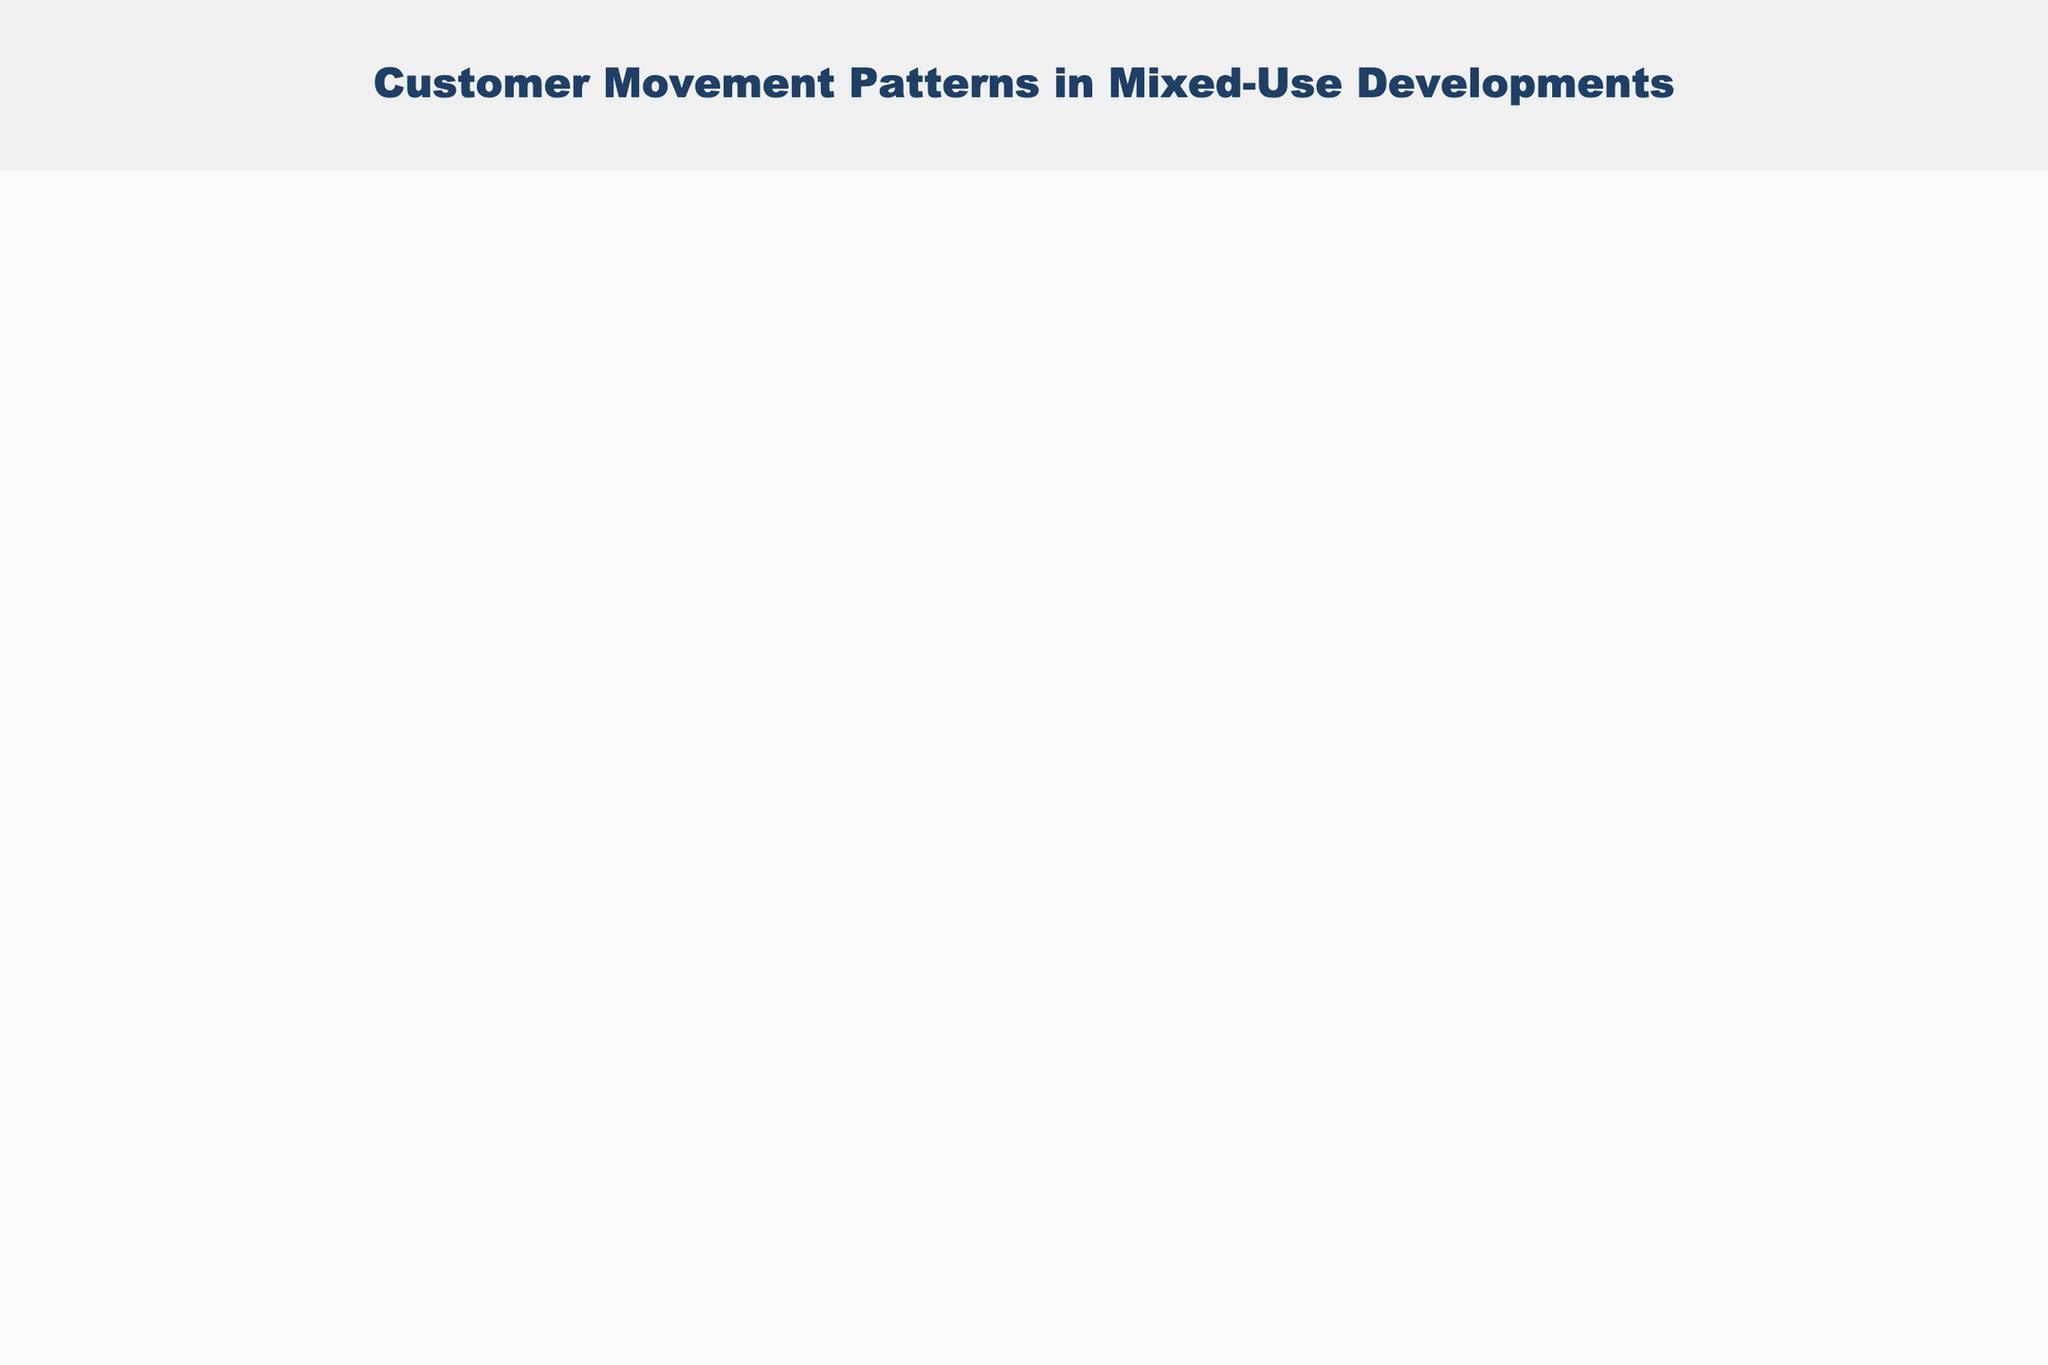What's the title of the quiver plot? The title of the quiver plot is written at the top of the plot.
Answer: "Customer Movement Patterns in Mixed-Use Developments" What are the ranges of the x and y axes? The x and y-axis ranges can be seen on the figure, indicated by the graduated tick marks and axis labels ranging from -1 to 6.
Answer: x: [-1, 6], y: [-1, 6] What does the annotation below the plot say? The annotation text is placed below the plot and provides context about the data.
Answer: "Data represents customer movement vectors in a retail space" How many data points are shown in the plot? The number of non-overlapping vectors represents the data points. Counting each vector head and tail visible in the figure will give the total number.
Answer: 15 Which vector has the longest magnitude, and what is its value? The vector magnitude is related to the arrow size; the longest arrow corresponds to the highest magnitude. The longest vector is at (1,4) with magnitude 3.0.
Answer: (1, 4), 3.0 Are there any vectors where movement is purely horizontal or vertical? To identify purely horizontal or vertical vectors, look for ones where either the u or v component is zero, respectively.
Answer: (4,3) is purely vertical, (1,4) is purely horizontal What is the color theme used for this plot? The color theme represents the magnitude of movement patterns; check the colors at each arrow to confirm the color scheme.
Answer: Viridis Which vectors start from the coordinates (0,0) and (2,1)? Reviewing the starting points in the data and comparing them with the plotted vectors we find these vectors easily. (0,0) is (2,1); (2,1) is (-1,2).
Answer: (0,0)=(2,1); (2,1)=(-1,2) How many vectors are pointing in the upward direction? Vectors pointing upward have a positive v component (vertical movement). Count the arrows pointing upwards.
Answer: 6 